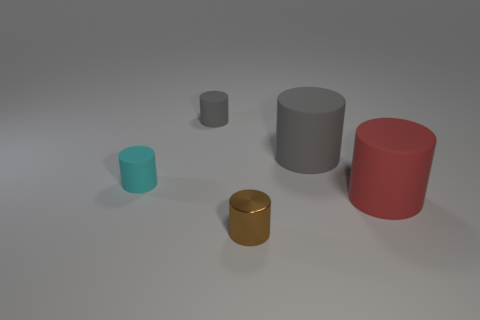How many total cylinders are there in this image, and can you describe their sizes in relation to each other? There are four cylinders in the image. Starting from the left, there's a small teal one, a miniature gray one, then the large gray one, and finally the red cylinder. Their sizes increase from the miniature gray to the large gray one, with the red and teal ones being of moderate and smaller sizes, respectively. 